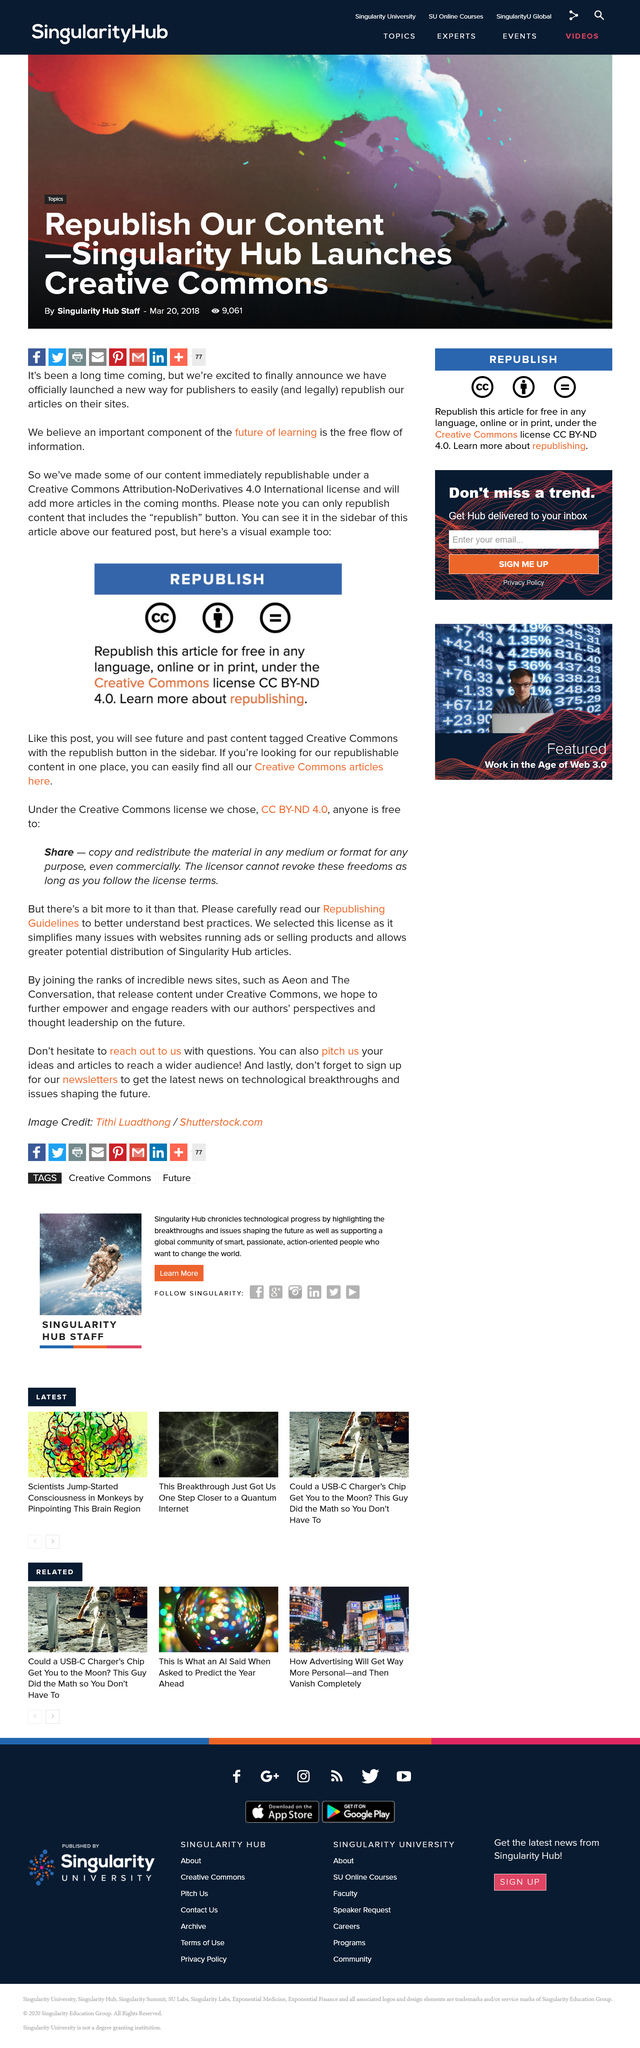Identify some key points in this picture. The republish button for content tagged with a Creative Commons license can be found in the sidebar. The content has been made immediately republishable under the Creative Commons Attribution-NoDerivatives 4.0 International license. It is only the content that includes the "republish" button that can be republished. 